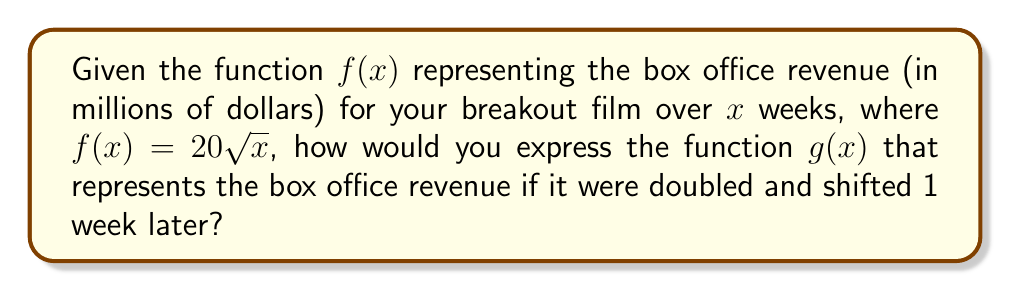Show me your answer to this math problem. To solve this problem, we need to apply two transformations to the original function $f(x) = 20\sqrt{x}$:

1. Doubling the revenue:
   This is a vertical stretch by a factor of 2. We multiply the entire function by 2.
   $2f(x) = 2(20\sqrt{x}) = 40\sqrt{x}$

2. Shifting 1 week later:
   This is a horizontal shift to the right by 1 unit. We replace $x$ with $(x-1)$.
   
Combining these transformations, we get:
$g(x) = 40\sqrt{x-1}$

To verify:
- When $x = 1$ (1 week after release), $g(1) = 40\sqrt{1-1} = 40\sqrt{0} = 0$, which is correct as the film hasn't been released yet.
- When $x = 2$ (2 weeks after release), $g(2) = 40\sqrt{2-1} = 40\sqrt{1} = 40$, which is double the original revenue at week 1.

Therefore, the function $g(x) = 40\sqrt{x-1}$ correctly represents the doubled revenue shifted 1 week later.
Answer: $g(x) = 40\sqrt{x-1}$ 